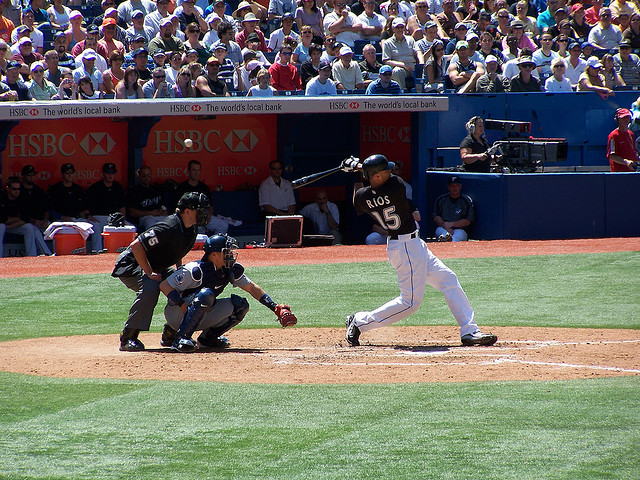<image>Is the batter left handed? I don't know if the batter is left handed. It can be either yes or no. Is the batter left handed? I don't know if the batter is left handed. It can be both left handed and right handed. 